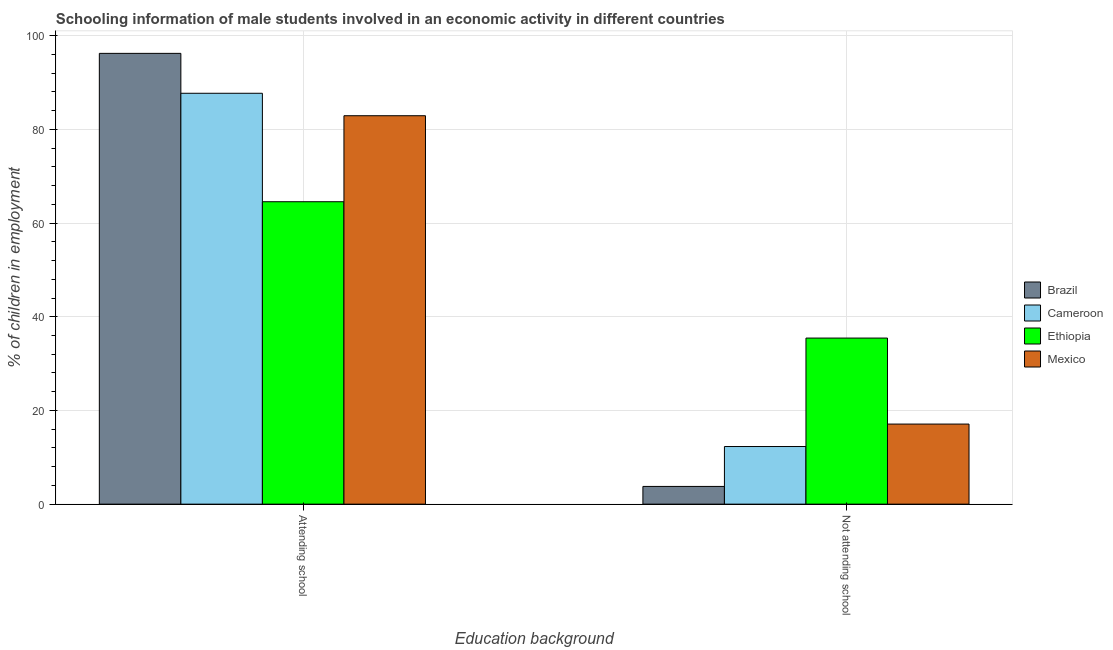How many different coloured bars are there?
Offer a very short reply. 4. How many bars are there on the 2nd tick from the right?
Provide a short and direct response. 4. What is the label of the 1st group of bars from the left?
Your answer should be compact. Attending school. What is the percentage of employed males who are not attending school in Brazil?
Offer a very short reply. 3.78. Across all countries, what is the maximum percentage of employed males who are attending school?
Your answer should be very brief. 96.22. Across all countries, what is the minimum percentage of employed males who are not attending school?
Your answer should be very brief. 3.78. In which country was the percentage of employed males who are not attending school maximum?
Provide a short and direct response. Ethiopia. What is the total percentage of employed males who are not attending school in the graph?
Provide a succinct answer. 68.63. What is the difference between the percentage of employed males who are attending school in Cameroon and that in Brazil?
Provide a succinct answer. -8.52. What is the difference between the percentage of employed males who are not attending school in Brazil and the percentage of employed males who are attending school in Cameroon?
Offer a terse response. -83.92. What is the average percentage of employed males who are not attending school per country?
Your response must be concise. 17.16. What is the difference between the percentage of employed males who are not attending school and percentage of employed males who are attending school in Cameroon?
Your answer should be very brief. -75.4. In how many countries, is the percentage of employed males who are attending school greater than 96 %?
Provide a succinct answer. 1. What is the ratio of the percentage of employed males who are attending school in Cameroon to that in Brazil?
Provide a succinct answer. 0.91. Is the percentage of employed males who are not attending school in Brazil less than that in Ethiopia?
Provide a short and direct response. Yes. What does the 4th bar from the left in Attending school represents?
Offer a terse response. Mexico. How many countries are there in the graph?
Make the answer very short. 4. What is the difference between two consecutive major ticks on the Y-axis?
Offer a very short reply. 20. Does the graph contain any zero values?
Your answer should be very brief. No. Does the graph contain grids?
Your answer should be very brief. Yes. Where does the legend appear in the graph?
Your answer should be compact. Center right. What is the title of the graph?
Make the answer very short. Schooling information of male students involved in an economic activity in different countries. What is the label or title of the X-axis?
Your response must be concise. Education background. What is the label or title of the Y-axis?
Give a very brief answer. % of children in employment. What is the % of children in employment in Brazil in Attending school?
Your response must be concise. 96.22. What is the % of children in employment in Cameroon in Attending school?
Offer a terse response. 87.7. What is the % of children in employment of Ethiopia in Attending school?
Offer a very short reply. 64.55. What is the % of children in employment in Mexico in Attending school?
Ensure brevity in your answer.  82.91. What is the % of children in employment of Brazil in Not attending school?
Provide a short and direct response. 3.78. What is the % of children in employment in Cameroon in Not attending school?
Your answer should be very brief. 12.3. What is the % of children in employment of Ethiopia in Not attending school?
Ensure brevity in your answer.  35.45. What is the % of children in employment in Mexico in Not attending school?
Ensure brevity in your answer.  17.09. Across all Education background, what is the maximum % of children in employment in Brazil?
Your response must be concise. 96.22. Across all Education background, what is the maximum % of children in employment in Cameroon?
Ensure brevity in your answer.  87.7. Across all Education background, what is the maximum % of children in employment of Ethiopia?
Offer a terse response. 64.55. Across all Education background, what is the maximum % of children in employment in Mexico?
Provide a short and direct response. 82.91. Across all Education background, what is the minimum % of children in employment in Brazil?
Give a very brief answer. 3.78. Across all Education background, what is the minimum % of children in employment in Ethiopia?
Offer a very short reply. 35.45. Across all Education background, what is the minimum % of children in employment in Mexico?
Give a very brief answer. 17.09. What is the total % of children in employment of Brazil in the graph?
Keep it short and to the point. 100. What is the total % of children in employment of Cameroon in the graph?
Offer a terse response. 100. What is the total % of children in employment of Ethiopia in the graph?
Provide a short and direct response. 100. What is the difference between the % of children in employment of Brazil in Attending school and that in Not attending school?
Offer a terse response. 92.43. What is the difference between the % of children in employment of Cameroon in Attending school and that in Not attending school?
Give a very brief answer. 75.4. What is the difference between the % of children in employment of Ethiopia in Attending school and that in Not attending school?
Your answer should be compact. 29.1. What is the difference between the % of children in employment of Mexico in Attending school and that in Not attending school?
Provide a succinct answer. 65.81. What is the difference between the % of children in employment in Brazil in Attending school and the % of children in employment in Cameroon in Not attending school?
Provide a succinct answer. 83.92. What is the difference between the % of children in employment in Brazil in Attending school and the % of children in employment in Ethiopia in Not attending school?
Give a very brief answer. 60.77. What is the difference between the % of children in employment in Brazil in Attending school and the % of children in employment in Mexico in Not attending school?
Provide a short and direct response. 79.12. What is the difference between the % of children in employment of Cameroon in Attending school and the % of children in employment of Ethiopia in Not attending school?
Provide a succinct answer. 52.25. What is the difference between the % of children in employment of Cameroon in Attending school and the % of children in employment of Mexico in Not attending school?
Provide a succinct answer. 70.61. What is the difference between the % of children in employment in Ethiopia in Attending school and the % of children in employment in Mexico in Not attending school?
Offer a terse response. 47.46. What is the difference between the % of children in employment of Brazil and % of children in employment of Cameroon in Attending school?
Keep it short and to the point. 8.52. What is the difference between the % of children in employment of Brazil and % of children in employment of Ethiopia in Attending school?
Offer a very short reply. 31.67. What is the difference between the % of children in employment of Brazil and % of children in employment of Mexico in Attending school?
Your answer should be very brief. 13.31. What is the difference between the % of children in employment in Cameroon and % of children in employment in Ethiopia in Attending school?
Offer a terse response. 23.15. What is the difference between the % of children in employment in Cameroon and % of children in employment in Mexico in Attending school?
Your response must be concise. 4.79. What is the difference between the % of children in employment in Ethiopia and % of children in employment in Mexico in Attending school?
Give a very brief answer. -18.36. What is the difference between the % of children in employment of Brazil and % of children in employment of Cameroon in Not attending school?
Provide a short and direct response. -8.52. What is the difference between the % of children in employment of Brazil and % of children in employment of Ethiopia in Not attending school?
Give a very brief answer. -31.67. What is the difference between the % of children in employment in Brazil and % of children in employment in Mexico in Not attending school?
Provide a short and direct response. -13.31. What is the difference between the % of children in employment of Cameroon and % of children in employment of Ethiopia in Not attending school?
Give a very brief answer. -23.15. What is the difference between the % of children in employment of Cameroon and % of children in employment of Mexico in Not attending school?
Make the answer very short. -4.79. What is the difference between the % of children in employment in Ethiopia and % of children in employment in Mexico in Not attending school?
Provide a short and direct response. 18.36. What is the ratio of the % of children in employment of Brazil in Attending school to that in Not attending school?
Offer a terse response. 25.43. What is the ratio of the % of children in employment in Cameroon in Attending school to that in Not attending school?
Provide a succinct answer. 7.13. What is the ratio of the % of children in employment of Ethiopia in Attending school to that in Not attending school?
Keep it short and to the point. 1.82. What is the ratio of the % of children in employment in Mexico in Attending school to that in Not attending school?
Offer a very short reply. 4.85. What is the difference between the highest and the second highest % of children in employment in Brazil?
Offer a very short reply. 92.43. What is the difference between the highest and the second highest % of children in employment in Cameroon?
Your response must be concise. 75.4. What is the difference between the highest and the second highest % of children in employment of Ethiopia?
Provide a short and direct response. 29.1. What is the difference between the highest and the second highest % of children in employment in Mexico?
Your answer should be compact. 65.81. What is the difference between the highest and the lowest % of children in employment in Brazil?
Provide a succinct answer. 92.43. What is the difference between the highest and the lowest % of children in employment in Cameroon?
Make the answer very short. 75.4. What is the difference between the highest and the lowest % of children in employment of Ethiopia?
Make the answer very short. 29.1. What is the difference between the highest and the lowest % of children in employment in Mexico?
Your response must be concise. 65.81. 